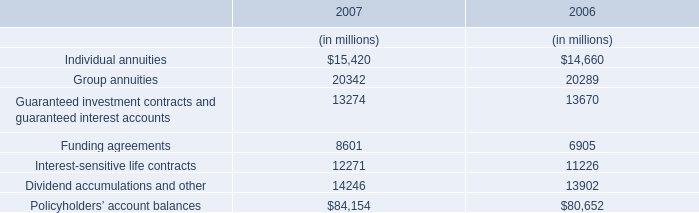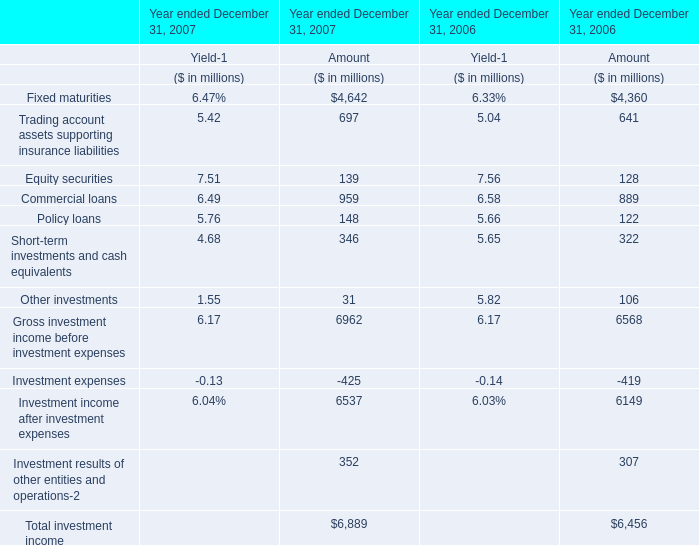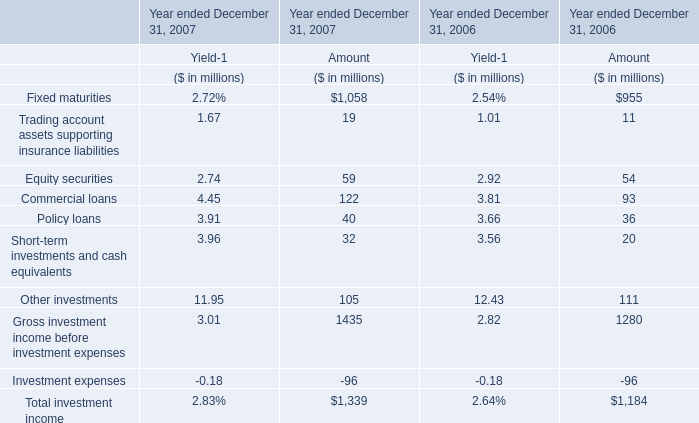The total amount of which section ranks first in 2007 for amount? 
Answer: Gross investment income before investment expenses. 